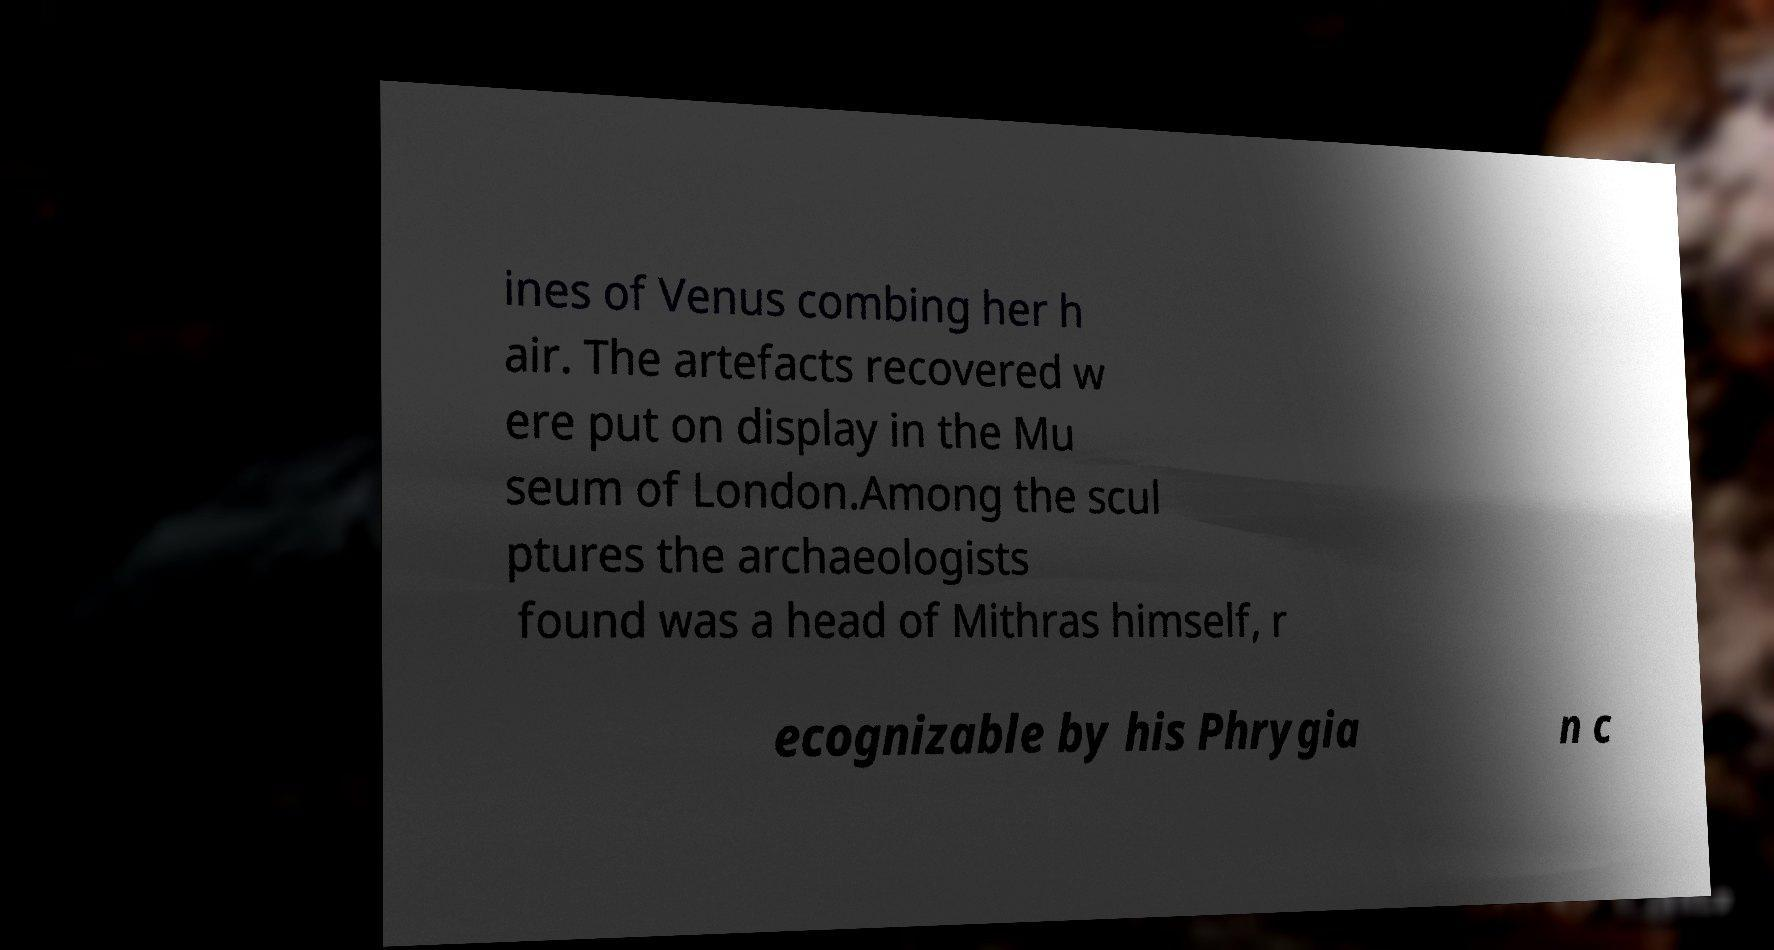There's text embedded in this image that I need extracted. Can you transcribe it verbatim? ines of Venus combing her h air. The artefacts recovered w ere put on display in the Mu seum of London.Among the scul ptures the archaeologists found was a head of Mithras himself, r ecognizable by his Phrygia n c 